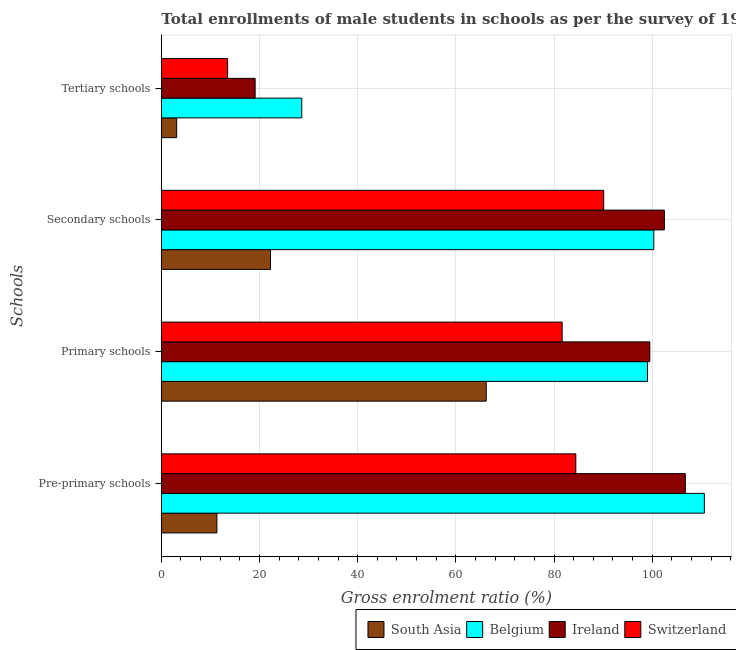How many different coloured bars are there?
Your answer should be compact. 4. How many groups of bars are there?
Provide a succinct answer. 4. How many bars are there on the 1st tick from the top?
Provide a succinct answer. 4. What is the label of the 4th group of bars from the top?
Ensure brevity in your answer.  Pre-primary schools. What is the gross enrolment ratio(male) in secondary schools in South Asia?
Offer a terse response. 22.24. Across all countries, what is the maximum gross enrolment ratio(male) in primary schools?
Make the answer very short. 99.5. Across all countries, what is the minimum gross enrolment ratio(male) in primary schools?
Make the answer very short. 66.18. In which country was the gross enrolment ratio(male) in pre-primary schools maximum?
Provide a short and direct response. Belgium. What is the total gross enrolment ratio(male) in pre-primary schools in the graph?
Give a very brief answer. 313.09. What is the difference between the gross enrolment ratio(male) in pre-primary schools in Belgium and that in Ireland?
Provide a short and direct response. 3.88. What is the difference between the gross enrolment ratio(male) in tertiary schools in South Asia and the gross enrolment ratio(male) in primary schools in Belgium?
Your answer should be very brief. -95.91. What is the average gross enrolment ratio(male) in tertiary schools per country?
Make the answer very short. 16.09. What is the difference between the gross enrolment ratio(male) in pre-primary schools and gross enrolment ratio(male) in secondary schools in South Asia?
Provide a short and direct response. -10.91. What is the ratio of the gross enrolment ratio(male) in tertiary schools in Belgium to that in South Asia?
Your response must be concise. 9.15. Is the difference between the gross enrolment ratio(male) in primary schools in Belgium and South Asia greater than the difference between the gross enrolment ratio(male) in tertiary schools in Belgium and South Asia?
Your answer should be compact. Yes. What is the difference between the highest and the second highest gross enrolment ratio(male) in secondary schools?
Offer a very short reply. 2.15. What is the difference between the highest and the lowest gross enrolment ratio(male) in primary schools?
Ensure brevity in your answer.  33.32. What does the 2nd bar from the top in Primary schools represents?
Offer a terse response. Ireland. What does the 4th bar from the bottom in Pre-primary schools represents?
Your answer should be compact. Switzerland. How many bars are there?
Make the answer very short. 16. Are all the bars in the graph horizontal?
Provide a succinct answer. Yes. What is the difference between two consecutive major ticks on the X-axis?
Give a very brief answer. 20. Does the graph contain any zero values?
Your response must be concise. No. Where does the legend appear in the graph?
Your answer should be very brief. Bottom right. How many legend labels are there?
Provide a succinct answer. 4. How are the legend labels stacked?
Keep it short and to the point. Horizontal. What is the title of the graph?
Provide a short and direct response. Total enrollments of male students in schools as per the survey of 1985 conducted in different countries. What is the label or title of the X-axis?
Provide a short and direct response. Gross enrolment ratio (%). What is the label or title of the Y-axis?
Keep it short and to the point. Schools. What is the Gross enrolment ratio (%) of South Asia in Pre-primary schools?
Keep it short and to the point. 11.32. What is the Gross enrolment ratio (%) in Belgium in Pre-primary schools?
Your response must be concise. 110.61. What is the Gross enrolment ratio (%) of Ireland in Pre-primary schools?
Keep it short and to the point. 106.73. What is the Gross enrolment ratio (%) in Switzerland in Pre-primary schools?
Your response must be concise. 84.43. What is the Gross enrolment ratio (%) in South Asia in Primary schools?
Ensure brevity in your answer.  66.18. What is the Gross enrolment ratio (%) in Belgium in Primary schools?
Provide a short and direct response. 99.04. What is the Gross enrolment ratio (%) in Ireland in Primary schools?
Your answer should be very brief. 99.5. What is the Gross enrolment ratio (%) in Switzerland in Primary schools?
Your answer should be very brief. 81.64. What is the Gross enrolment ratio (%) in South Asia in Secondary schools?
Your response must be concise. 22.24. What is the Gross enrolment ratio (%) of Belgium in Secondary schools?
Make the answer very short. 100.31. What is the Gross enrolment ratio (%) of Ireland in Secondary schools?
Make the answer very short. 102.47. What is the Gross enrolment ratio (%) of Switzerland in Secondary schools?
Give a very brief answer. 90.11. What is the Gross enrolment ratio (%) in South Asia in Tertiary schools?
Provide a succinct answer. 3.13. What is the Gross enrolment ratio (%) of Belgium in Tertiary schools?
Ensure brevity in your answer.  28.61. What is the Gross enrolment ratio (%) of Ireland in Tertiary schools?
Offer a very short reply. 19.11. What is the Gross enrolment ratio (%) in Switzerland in Tertiary schools?
Provide a succinct answer. 13.51. Across all Schools, what is the maximum Gross enrolment ratio (%) in South Asia?
Offer a very short reply. 66.18. Across all Schools, what is the maximum Gross enrolment ratio (%) in Belgium?
Make the answer very short. 110.61. Across all Schools, what is the maximum Gross enrolment ratio (%) in Ireland?
Keep it short and to the point. 106.73. Across all Schools, what is the maximum Gross enrolment ratio (%) in Switzerland?
Make the answer very short. 90.11. Across all Schools, what is the minimum Gross enrolment ratio (%) in South Asia?
Provide a succinct answer. 3.13. Across all Schools, what is the minimum Gross enrolment ratio (%) in Belgium?
Provide a short and direct response. 28.61. Across all Schools, what is the minimum Gross enrolment ratio (%) in Ireland?
Keep it short and to the point. 19.11. Across all Schools, what is the minimum Gross enrolment ratio (%) in Switzerland?
Provide a short and direct response. 13.51. What is the total Gross enrolment ratio (%) in South Asia in the graph?
Your answer should be compact. 102.86. What is the total Gross enrolment ratio (%) of Belgium in the graph?
Provide a succinct answer. 338.57. What is the total Gross enrolment ratio (%) in Ireland in the graph?
Offer a terse response. 327.81. What is the total Gross enrolment ratio (%) in Switzerland in the graph?
Give a very brief answer. 269.69. What is the difference between the Gross enrolment ratio (%) in South Asia in Pre-primary schools and that in Primary schools?
Make the answer very short. -54.85. What is the difference between the Gross enrolment ratio (%) of Belgium in Pre-primary schools and that in Primary schools?
Offer a terse response. 11.57. What is the difference between the Gross enrolment ratio (%) in Ireland in Pre-primary schools and that in Primary schools?
Your response must be concise. 7.23. What is the difference between the Gross enrolment ratio (%) of Switzerland in Pre-primary schools and that in Primary schools?
Ensure brevity in your answer.  2.79. What is the difference between the Gross enrolment ratio (%) in South Asia in Pre-primary schools and that in Secondary schools?
Provide a short and direct response. -10.91. What is the difference between the Gross enrolment ratio (%) of Belgium in Pre-primary schools and that in Secondary schools?
Offer a terse response. 10.29. What is the difference between the Gross enrolment ratio (%) in Ireland in Pre-primary schools and that in Secondary schools?
Offer a very short reply. 4.27. What is the difference between the Gross enrolment ratio (%) in Switzerland in Pre-primary schools and that in Secondary schools?
Give a very brief answer. -5.68. What is the difference between the Gross enrolment ratio (%) of South Asia in Pre-primary schools and that in Tertiary schools?
Keep it short and to the point. 8.2. What is the difference between the Gross enrolment ratio (%) in Belgium in Pre-primary schools and that in Tertiary schools?
Make the answer very short. 82. What is the difference between the Gross enrolment ratio (%) in Ireland in Pre-primary schools and that in Tertiary schools?
Make the answer very short. 87.62. What is the difference between the Gross enrolment ratio (%) of Switzerland in Pre-primary schools and that in Tertiary schools?
Your answer should be very brief. 70.92. What is the difference between the Gross enrolment ratio (%) in South Asia in Primary schools and that in Secondary schools?
Give a very brief answer. 43.94. What is the difference between the Gross enrolment ratio (%) in Belgium in Primary schools and that in Secondary schools?
Offer a terse response. -1.28. What is the difference between the Gross enrolment ratio (%) in Ireland in Primary schools and that in Secondary schools?
Your response must be concise. -2.96. What is the difference between the Gross enrolment ratio (%) of Switzerland in Primary schools and that in Secondary schools?
Your response must be concise. -8.47. What is the difference between the Gross enrolment ratio (%) in South Asia in Primary schools and that in Tertiary schools?
Keep it short and to the point. 63.05. What is the difference between the Gross enrolment ratio (%) of Belgium in Primary schools and that in Tertiary schools?
Offer a terse response. 70.43. What is the difference between the Gross enrolment ratio (%) in Ireland in Primary schools and that in Tertiary schools?
Offer a very short reply. 80.39. What is the difference between the Gross enrolment ratio (%) in Switzerland in Primary schools and that in Tertiary schools?
Provide a succinct answer. 68.13. What is the difference between the Gross enrolment ratio (%) of South Asia in Secondary schools and that in Tertiary schools?
Provide a short and direct response. 19.11. What is the difference between the Gross enrolment ratio (%) of Belgium in Secondary schools and that in Tertiary schools?
Provide a short and direct response. 71.7. What is the difference between the Gross enrolment ratio (%) in Ireland in Secondary schools and that in Tertiary schools?
Offer a very short reply. 83.36. What is the difference between the Gross enrolment ratio (%) of Switzerland in Secondary schools and that in Tertiary schools?
Offer a terse response. 76.6. What is the difference between the Gross enrolment ratio (%) in South Asia in Pre-primary schools and the Gross enrolment ratio (%) in Belgium in Primary schools?
Your answer should be compact. -87.71. What is the difference between the Gross enrolment ratio (%) of South Asia in Pre-primary schools and the Gross enrolment ratio (%) of Ireland in Primary schools?
Ensure brevity in your answer.  -88.18. What is the difference between the Gross enrolment ratio (%) of South Asia in Pre-primary schools and the Gross enrolment ratio (%) of Switzerland in Primary schools?
Give a very brief answer. -70.32. What is the difference between the Gross enrolment ratio (%) of Belgium in Pre-primary schools and the Gross enrolment ratio (%) of Ireland in Primary schools?
Provide a short and direct response. 11.11. What is the difference between the Gross enrolment ratio (%) of Belgium in Pre-primary schools and the Gross enrolment ratio (%) of Switzerland in Primary schools?
Your answer should be compact. 28.96. What is the difference between the Gross enrolment ratio (%) in Ireland in Pre-primary schools and the Gross enrolment ratio (%) in Switzerland in Primary schools?
Give a very brief answer. 25.09. What is the difference between the Gross enrolment ratio (%) of South Asia in Pre-primary schools and the Gross enrolment ratio (%) of Belgium in Secondary schools?
Your response must be concise. -88.99. What is the difference between the Gross enrolment ratio (%) of South Asia in Pre-primary schools and the Gross enrolment ratio (%) of Ireland in Secondary schools?
Give a very brief answer. -91.14. What is the difference between the Gross enrolment ratio (%) in South Asia in Pre-primary schools and the Gross enrolment ratio (%) in Switzerland in Secondary schools?
Provide a short and direct response. -78.79. What is the difference between the Gross enrolment ratio (%) in Belgium in Pre-primary schools and the Gross enrolment ratio (%) in Ireland in Secondary schools?
Provide a succinct answer. 8.14. What is the difference between the Gross enrolment ratio (%) in Belgium in Pre-primary schools and the Gross enrolment ratio (%) in Switzerland in Secondary schools?
Make the answer very short. 20.5. What is the difference between the Gross enrolment ratio (%) of Ireland in Pre-primary schools and the Gross enrolment ratio (%) of Switzerland in Secondary schools?
Your response must be concise. 16.62. What is the difference between the Gross enrolment ratio (%) in South Asia in Pre-primary schools and the Gross enrolment ratio (%) in Belgium in Tertiary schools?
Ensure brevity in your answer.  -17.29. What is the difference between the Gross enrolment ratio (%) of South Asia in Pre-primary schools and the Gross enrolment ratio (%) of Ireland in Tertiary schools?
Your answer should be very brief. -7.78. What is the difference between the Gross enrolment ratio (%) in South Asia in Pre-primary schools and the Gross enrolment ratio (%) in Switzerland in Tertiary schools?
Your answer should be very brief. -2.18. What is the difference between the Gross enrolment ratio (%) in Belgium in Pre-primary schools and the Gross enrolment ratio (%) in Ireland in Tertiary schools?
Provide a succinct answer. 91.5. What is the difference between the Gross enrolment ratio (%) in Belgium in Pre-primary schools and the Gross enrolment ratio (%) in Switzerland in Tertiary schools?
Offer a terse response. 97.1. What is the difference between the Gross enrolment ratio (%) of Ireland in Pre-primary schools and the Gross enrolment ratio (%) of Switzerland in Tertiary schools?
Provide a short and direct response. 93.22. What is the difference between the Gross enrolment ratio (%) in South Asia in Primary schools and the Gross enrolment ratio (%) in Belgium in Secondary schools?
Give a very brief answer. -34.14. What is the difference between the Gross enrolment ratio (%) in South Asia in Primary schools and the Gross enrolment ratio (%) in Ireland in Secondary schools?
Provide a succinct answer. -36.29. What is the difference between the Gross enrolment ratio (%) of South Asia in Primary schools and the Gross enrolment ratio (%) of Switzerland in Secondary schools?
Give a very brief answer. -23.93. What is the difference between the Gross enrolment ratio (%) in Belgium in Primary schools and the Gross enrolment ratio (%) in Ireland in Secondary schools?
Your response must be concise. -3.43. What is the difference between the Gross enrolment ratio (%) of Belgium in Primary schools and the Gross enrolment ratio (%) of Switzerland in Secondary schools?
Your response must be concise. 8.93. What is the difference between the Gross enrolment ratio (%) in Ireland in Primary schools and the Gross enrolment ratio (%) in Switzerland in Secondary schools?
Provide a succinct answer. 9.39. What is the difference between the Gross enrolment ratio (%) of South Asia in Primary schools and the Gross enrolment ratio (%) of Belgium in Tertiary schools?
Offer a terse response. 37.57. What is the difference between the Gross enrolment ratio (%) in South Asia in Primary schools and the Gross enrolment ratio (%) in Ireland in Tertiary schools?
Offer a very short reply. 47.07. What is the difference between the Gross enrolment ratio (%) of South Asia in Primary schools and the Gross enrolment ratio (%) of Switzerland in Tertiary schools?
Make the answer very short. 52.67. What is the difference between the Gross enrolment ratio (%) of Belgium in Primary schools and the Gross enrolment ratio (%) of Ireland in Tertiary schools?
Keep it short and to the point. 79.93. What is the difference between the Gross enrolment ratio (%) in Belgium in Primary schools and the Gross enrolment ratio (%) in Switzerland in Tertiary schools?
Your answer should be compact. 85.53. What is the difference between the Gross enrolment ratio (%) of Ireland in Primary schools and the Gross enrolment ratio (%) of Switzerland in Tertiary schools?
Ensure brevity in your answer.  85.99. What is the difference between the Gross enrolment ratio (%) in South Asia in Secondary schools and the Gross enrolment ratio (%) in Belgium in Tertiary schools?
Your response must be concise. -6.37. What is the difference between the Gross enrolment ratio (%) in South Asia in Secondary schools and the Gross enrolment ratio (%) in Ireland in Tertiary schools?
Make the answer very short. 3.13. What is the difference between the Gross enrolment ratio (%) of South Asia in Secondary schools and the Gross enrolment ratio (%) of Switzerland in Tertiary schools?
Provide a short and direct response. 8.73. What is the difference between the Gross enrolment ratio (%) of Belgium in Secondary schools and the Gross enrolment ratio (%) of Ireland in Tertiary schools?
Keep it short and to the point. 81.21. What is the difference between the Gross enrolment ratio (%) in Belgium in Secondary schools and the Gross enrolment ratio (%) in Switzerland in Tertiary schools?
Give a very brief answer. 86.81. What is the difference between the Gross enrolment ratio (%) in Ireland in Secondary schools and the Gross enrolment ratio (%) in Switzerland in Tertiary schools?
Offer a very short reply. 88.96. What is the average Gross enrolment ratio (%) in South Asia per Schools?
Provide a short and direct response. 25.72. What is the average Gross enrolment ratio (%) in Belgium per Schools?
Give a very brief answer. 84.64. What is the average Gross enrolment ratio (%) of Ireland per Schools?
Provide a succinct answer. 81.95. What is the average Gross enrolment ratio (%) of Switzerland per Schools?
Ensure brevity in your answer.  67.42. What is the difference between the Gross enrolment ratio (%) of South Asia and Gross enrolment ratio (%) of Belgium in Pre-primary schools?
Your response must be concise. -99.28. What is the difference between the Gross enrolment ratio (%) of South Asia and Gross enrolment ratio (%) of Ireland in Pre-primary schools?
Your answer should be very brief. -95.41. What is the difference between the Gross enrolment ratio (%) in South Asia and Gross enrolment ratio (%) in Switzerland in Pre-primary schools?
Offer a very short reply. -73.1. What is the difference between the Gross enrolment ratio (%) in Belgium and Gross enrolment ratio (%) in Ireland in Pre-primary schools?
Make the answer very short. 3.88. What is the difference between the Gross enrolment ratio (%) in Belgium and Gross enrolment ratio (%) in Switzerland in Pre-primary schools?
Give a very brief answer. 26.18. What is the difference between the Gross enrolment ratio (%) of Ireland and Gross enrolment ratio (%) of Switzerland in Pre-primary schools?
Provide a succinct answer. 22.3. What is the difference between the Gross enrolment ratio (%) of South Asia and Gross enrolment ratio (%) of Belgium in Primary schools?
Offer a very short reply. -32.86. What is the difference between the Gross enrolment ratio (%) of South Asia and Gross enrolment ratio (%) of Ireland in Primary schools?
Your answer should be compact. -33.32. What is the difference between the Gross enrolment ratio (%) of South Asia and Gross enrolment ratio (%) of Switzerland in Primary schools?
Give a very brief answer. -15.47. What is the difference between the Gross enrolment ratio (%) in Belgium and Gross enrolment ratio (%) in Ireland in Primary schools?
Your answer should be very brief. -0.46. What is the difference between the Gross enrolment ratio (%) in Belgium and Gross enrolment ratio (%) in Switzerland in Primary schools?
Provide a succinct answer. 17.4. What is the difference between the Gross enrolment ratio (%) of Ireland and Gross enrolment ratio (%) of Switzerland in Primary schools?
Your answer should be very brief. 17.86. What is the difference between the Gross enrolment ratio (%) of South Asia and Gross enrolment ratio (%) of Belgium in Secondary schools?
Ensure brevity in your answer.  -78.08. What is the difference between the Gross enrolment ratio (%) in South Asia and Gross enrolment ratio (%) in Ireland in Secondary schools?
Your answer should be compact. -80.23. What is the difference between the Gross enrolment ratio (%) of South Asia and Gross enrolment ratio (%) of Switzerland in Secondary schools?
Ensure brevity in your answer.  -67.87. What is the difference between the Gross enrolment ratio (%) in Belgium and Gross enrolment ratio (%) in Ireland in Secondary schools?
Your answer should be compact. -2.15. What is the difference between the Gross enrolment ratio (%) of Belgium and Gross enrolment ratio (%) of Switzerland in Secondary schools?
Give a very brief answer. 10.2. What is the difference between the Gross enrolment ratio (%) in Ireland and Gross enrolment ratio (%) in Switzerland in Secondary schools?
Give a very brief answer. 12.36. What is the difference between the Gross enrolment ratio (%) in South Asia and Gross enrolment ratio (%) in Belgium in Tertiary schools?
Your answer should be compact. -25.48. What is the difference between the Gross enrolment ratio (%) of South Asia and Gross enrolment ratio (%) of Ireland in Tertiary schools?
Offer a very short reply. -15.98. What is the difference between the Gross enrolment ratio (%) in South Asia and Gross enrolment ratio (%) in Switzerland in Tertiary schools?
Provide a succinct answer. -10.38. What is the difference between the Gross enrolment ratio (%) of Belgium and Gross enrolment ratio (%) of Ireland in Tertiary schools?
Keep it short and to the point. 9.5. What is the difference between the Gross enrolment ratio (%) in Belgium and Gross enrolment ratio (%) in Switzerland in Tertiary schools?
Keep it short and to the point. 15.1. What is the difference between the Gross enrolment ratio (%) of Ireland and Gross enrolment ratio (%) of Switzerland in Tertiary schools?
Provide a succinct answer. 5.6. What is the ratio of the Gross enrolment ratio (%) in South Asia in Pre-primary schools to that in Primary schools?
Keep it short and to the point. 0.17. What is the ratio of the Gross enrolment ratio (%) in Belgium in Pre-primary schools to that in Primary schools?
Make the answer very short. 1.12. What is the ratio of the Gross enrolment ratio (%) in Ireland in Pre-primary schools to that in Primary schools?
Provide a succinct answer. 1.07. What is the ratio of the Gross enrolment ratio (%) of Switzerland in Pre-primary schools to that in Primary schools?
Offer a very short reply. 1.03. What is the ratio of the Gross enrolment ratio (%) of South Asia in Pre-primary schools to that in Secondary schools?
Keep it short and to the point. 0.51. What is the ratio of the Gross enrolment ratio (%) of Belgium in Pre-primary schools to that in Secondary schools?
Make the answer very short. 1.1. What is the ratio of the Gross enrolment ratio (%) of Ireland in Pre-primary schools to that in Secondary schools?
Provide a short and direct response. 1.04. What is the ratio of the Gross enrolment ratio (%) of Switzerland in Pre-primary schools to that in Secondary schools?
Provide a short and direct response. 0.94. What is the ratio of the Gross enrolment ratio (%) of South Asia in Pre-primary schools to that in Tertiary schools?
Your response must be concise. 3.62. What is the ratio of the Gross enrolment ratio (%) in Belgium in Pre-primary schools to that in Tertiary schools?
Offer a very short reply. 3.87. What is the ratio of the Gross enrolment ratio (%) of Ireland in Pre-primary schools to that in Tertiary schools?
Your response must be concise. 5.59. What is the ratio of the Gross enrolment ratio (%) of Switzerland in Pre-primary schools to that in Tertiary schools?
Your response must be concise. 6.25. What is the ratio of the Gross enrolment ratio (%) in South Asia in Primary schools to that in Secondary schools?
Offer a terse response. 2.98. What is the ratio of the Gross enrolment ratio (%) in Belgium in Primary schools to that in Secondary schools?
Make the answer very short. 0.99. What is the ratio of the Gross enrolment ratio (%) of Ireland in Primary schools to that in Secondary schools?
Keep it short and to the point. 0.97. What is the ratio of the Gross enrolment ratio (%) of Switzerland in Primary schools to that in Secondary schools?
Your answer should be very brief. 0.91. What is the ratio of the Gross enrolment ratio (%) of South Asia in Primary schools to that in Tertiary schools?
Ensure brevity in your answer.  21.16. What is the ratio of the Gross enrolment ratio (%) in Belgium in Primary schools to that in Tertiary schools?
Give a very brief answer. 3.46. What is the ratio of the Gross enrolment ratio (%) of Ireland in Primary schools to that in Tertiary schools?
Make the answer very short. 5.21. What is the ratio of the Gross enrolment ratio (%) in Switzerland in Primary schools to that in Tertiary schools?
Provide a short and direct response. 6.04. What is the ratio of the Gross enrolment ratio (%) of South Asia in Secondary schools to that in Tertiary schools?
Your response must be concise. 7.11. What is the ratio of the Gross enrolment ratio (%) of Belgium in Secondary schools to that in Tertiary schools?
Your response must be concise. 3.51. What is the ratio of the Gross enrolment ratio (%) of Ireland in Secondary schools to that in Tertiary schools?
Offer a terse response. 5.36. What is the ratio of the Gross enrolment ratio (%) of Switzerland in Secondary schools to that in Tertiary schools?
Give a very brief answer. 6.67. What is the difference between the highest and the second highest Gross enrolment ratio (%) in South Asia?
Your answer should be compact. 43.94. What is the difference between the highest and the second highest Gross enrolment ratio (%) in Belgium?
Make the answer very short. 10.29. What is the difference between the highest and the second highest Gross enrolment ratio (%) in Ireland?
Give a very brief answer. 4.27. What is the difference between the highest and the second highest Gross enrolment ratio (%) in Switzerland?
Your response must be concise. 5.68. What is the difference between the highest and the lowest Gross enrolment ratio (%) in South Asia?
Offer a very short reply. 63.05. What is the difference between the highest and the lowest Gross enrolment ratio (%) of Belgium?
Offer a terse response. 82. What is the difference between the highest and the lowest Gross enrolment ratio (%) in Ireland?
Your answer should be compact. 87.62. What is the difference between the highest and the lowest Gross enrolment ratio (%) in Switzerland?
Provide a succinct answer. 76.6. 